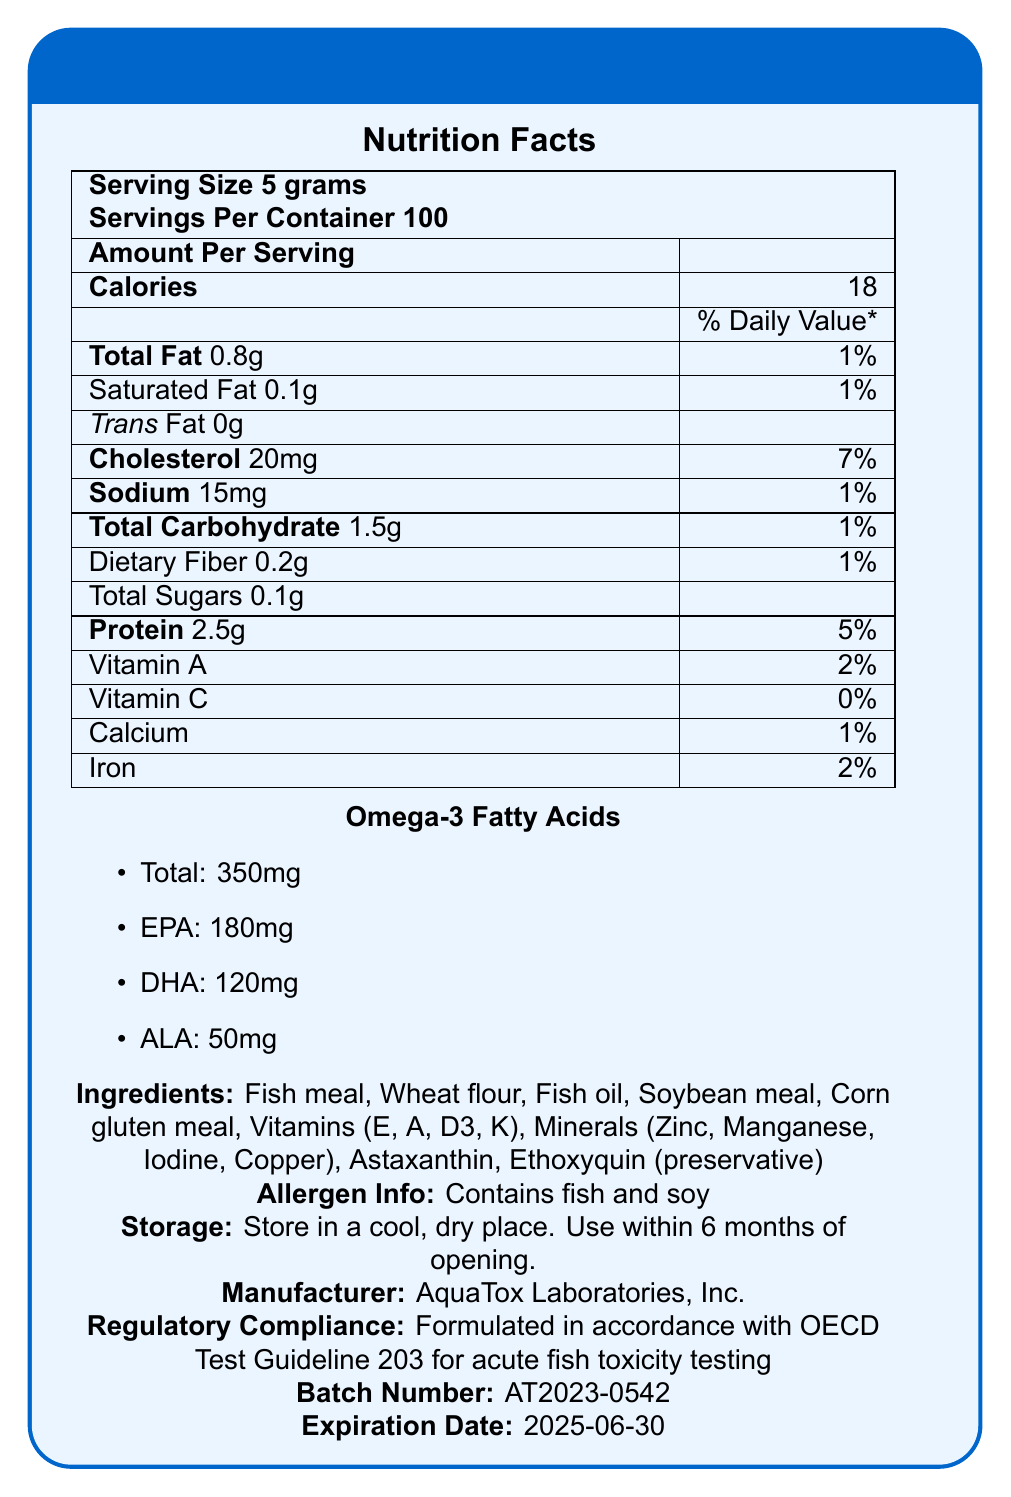what is the serving size for AquaTox Pro Fish Food? The serving size is stated clearly in the second line of the Nutrition Facts section.
Answer: 5 grams how many servings are there per container? This information is provided right next to the serving size in the Nutrition Facts section.
Answer: 100 what is the amount of omega-3 fatty acids in one serving? The specific amount of omega-3 fatty acids is detailed under the Omega-3 Fatty Acids section.
Answer: 350mg how many grams of protein are there in one serving? The amount of protein per serving is listed in the Nutrition Facts table.
Answer: 2.5g what is the percentage of daily value for sodium per serving? The percentage daily value for sodium is shown in the Nutrition Facts table.
Answer: 1% which ingredient in AquaTox Pro Fish Food acts as a preservative? A. Fish oil B. Ethoxyquin C. Astaxanthin D. Soybean meal Ethoxyquin is indicated as a preservative in the ingredients list.
Answer: B which of the following is NOT a vitamin included in the ingredients? A. Vitamin E B. Vitamin A C. Vitamin C D. Vitamin D3 Vitamin C is not listed in the vitamins included in the ingredients.
Answer: C does AquaTox Pro Fish Food contain any allergens? The allergen information clearly states that it contains fish and soy.
Answer: Yes is the product formulated in compliance with any guidelines? It is formulated in accordance with OECD Test Guideline 203 for acute fish toxicity testing.
Answer: Yes summarize the main idea of the document The document provides comprehensive details about AquaTox Pro Fish Food, including nutritional values, ingredients, compliance with regulatory guidelines, and usage instructions.
Answer: AquaTox Pro Fish Food is a specially formulated fish food designed for aquatic toxicity testing. It provides nutritional information per serving, including omega-3 fatty acid levels and other key nutritional components. The document also lists ingredients, allergens, storage instructions, manufacturer details, regulatory compliance, and expiration date. what is the cholesterol amount per serving in AquaTox Pro Fish Food? The cholesterol amount is specified in the Nutrition Facts section.
Answer: 20mg what is the manufacturer's name? The manufacturer's name is provided at the end of the document.
Answer: AquaTox Laboratories, Inc. what is the expiration date of the product? The expiration date is given at the end of the document.
Answer: 2025-06-30 is the total carbohydrate content in one serving higher than the total fat content? The total carbohydrate content is 1.5g, whereas the total fat content is 0.8g.
Answer: No what kind of place should the product be stored in? The storage instructions specify that the product should be stored in a cool, dry place.
Answer: A cool, dry place what are the proportions of EPA, DHA, and ALA in the omega-3 fatty acids? The proportions of these omega-3 fatty acids are listed under the Omega-3 Fatty Acids section.
Answer: EPA: 180mg, DHA: 120mg, ALA: 50mg how much total fiber does one serving of AquaTox Pro Fish Food contain? The dietary fiber content is clearly stated in the Nutrition Facts section.
Answer: 0.2g does the product contain Vitamin C? The percentage daily value for Vitamin C is listed as 0%.
Answer: No what is the batch number of the product? The batch number is provided at the end of the document.
Answer: AT2023-0542 how many calories does one serving of AquaTox Pro Fish Food provide? The calorie content per serving is specified in the Nutrition Facts section.
Answer: 18 what is the proportion of carbohydrates to total fat per serving? This can be determined from the values provided for total carbohydrates and total fat in the Nutrition Facts section.
Answer: 1.5g to 0.8g how often should the product be used within after opening? The storage instructions indicate that the product should be used within 6 months of opening.
Answer: Within 6 months who is the intended audience for the document? The document does not specify the intended audience directly.
Answer: Cannot be determined 